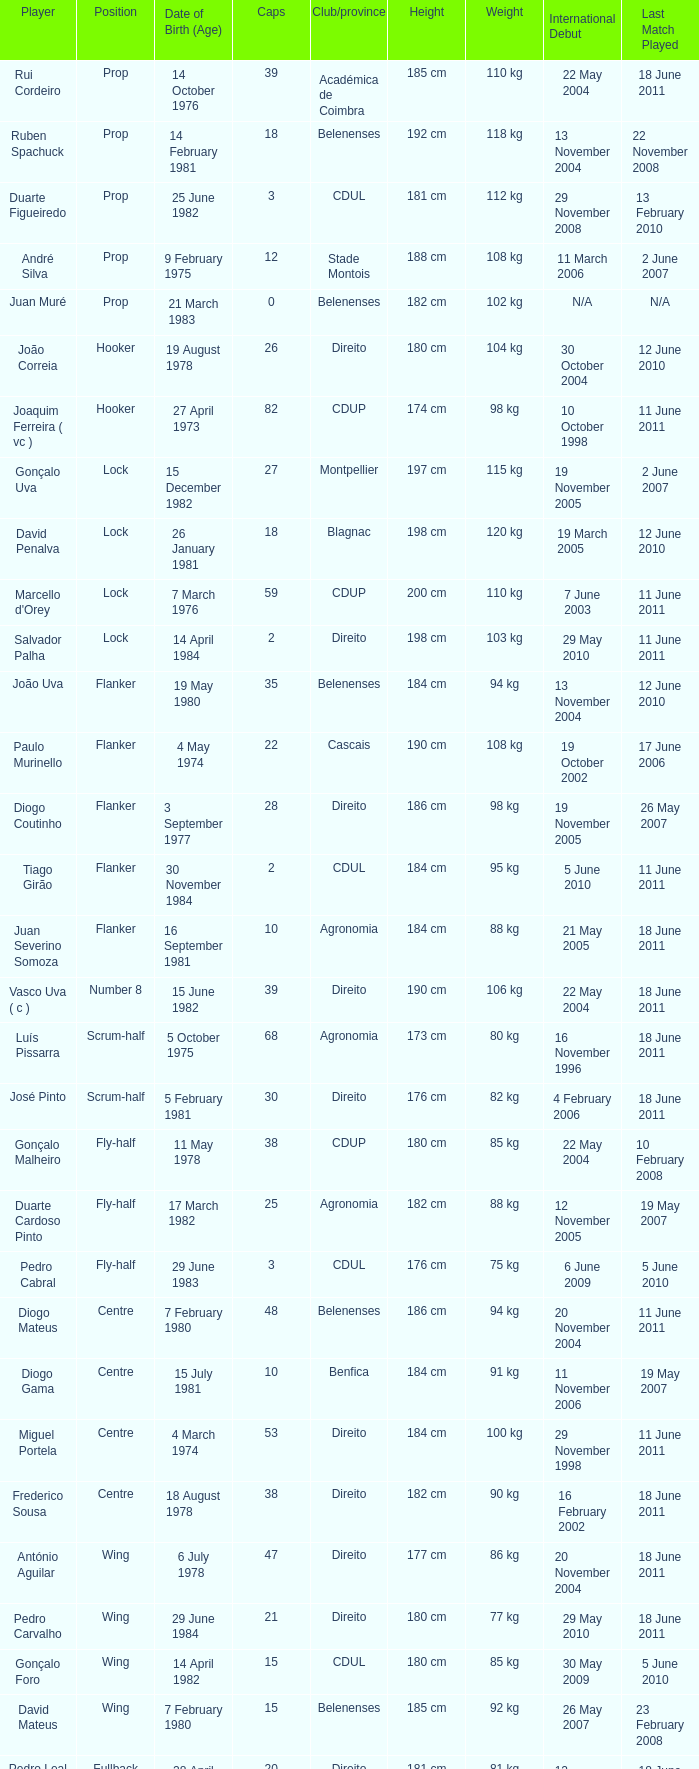Which player has a Position of fly-half, and a Caps of 3? Pedro Cabral. 